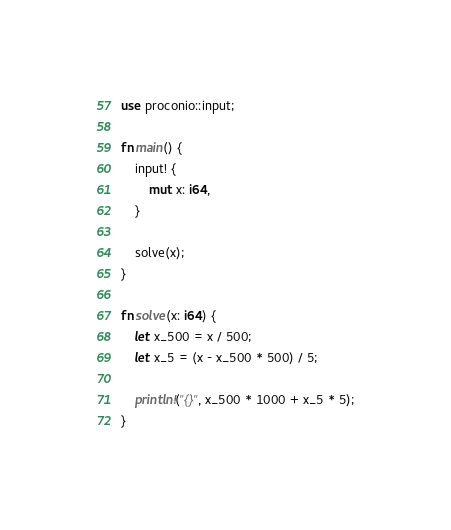Convert code to text. <code><loc_0><loc_0><loc_500><loc_500><_Rust_>use proconio::input;

fn main() {
    input! {
        mut x: i64,
    }

    solve(x);
}

fn solve(x: i64) {
    let x_500 = x / 500;
    let x_5 = (x - x_500 * 500) / 5;

    println!("{}", x_500 * 1000 + x_5 * 5);
}
</code> 